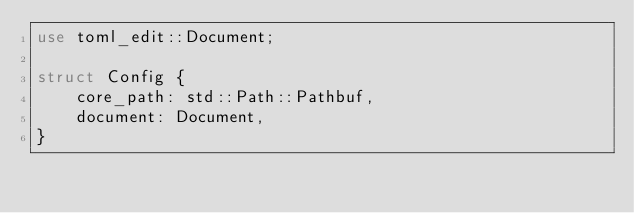Convert code to text. <code><loc_0><loc_0><loc_500><loc_500><_Rust_>use toml_edit::Document;

struct Config {
    core_path: std::Path::Pathbuf,
    document: Document,
}</code> 